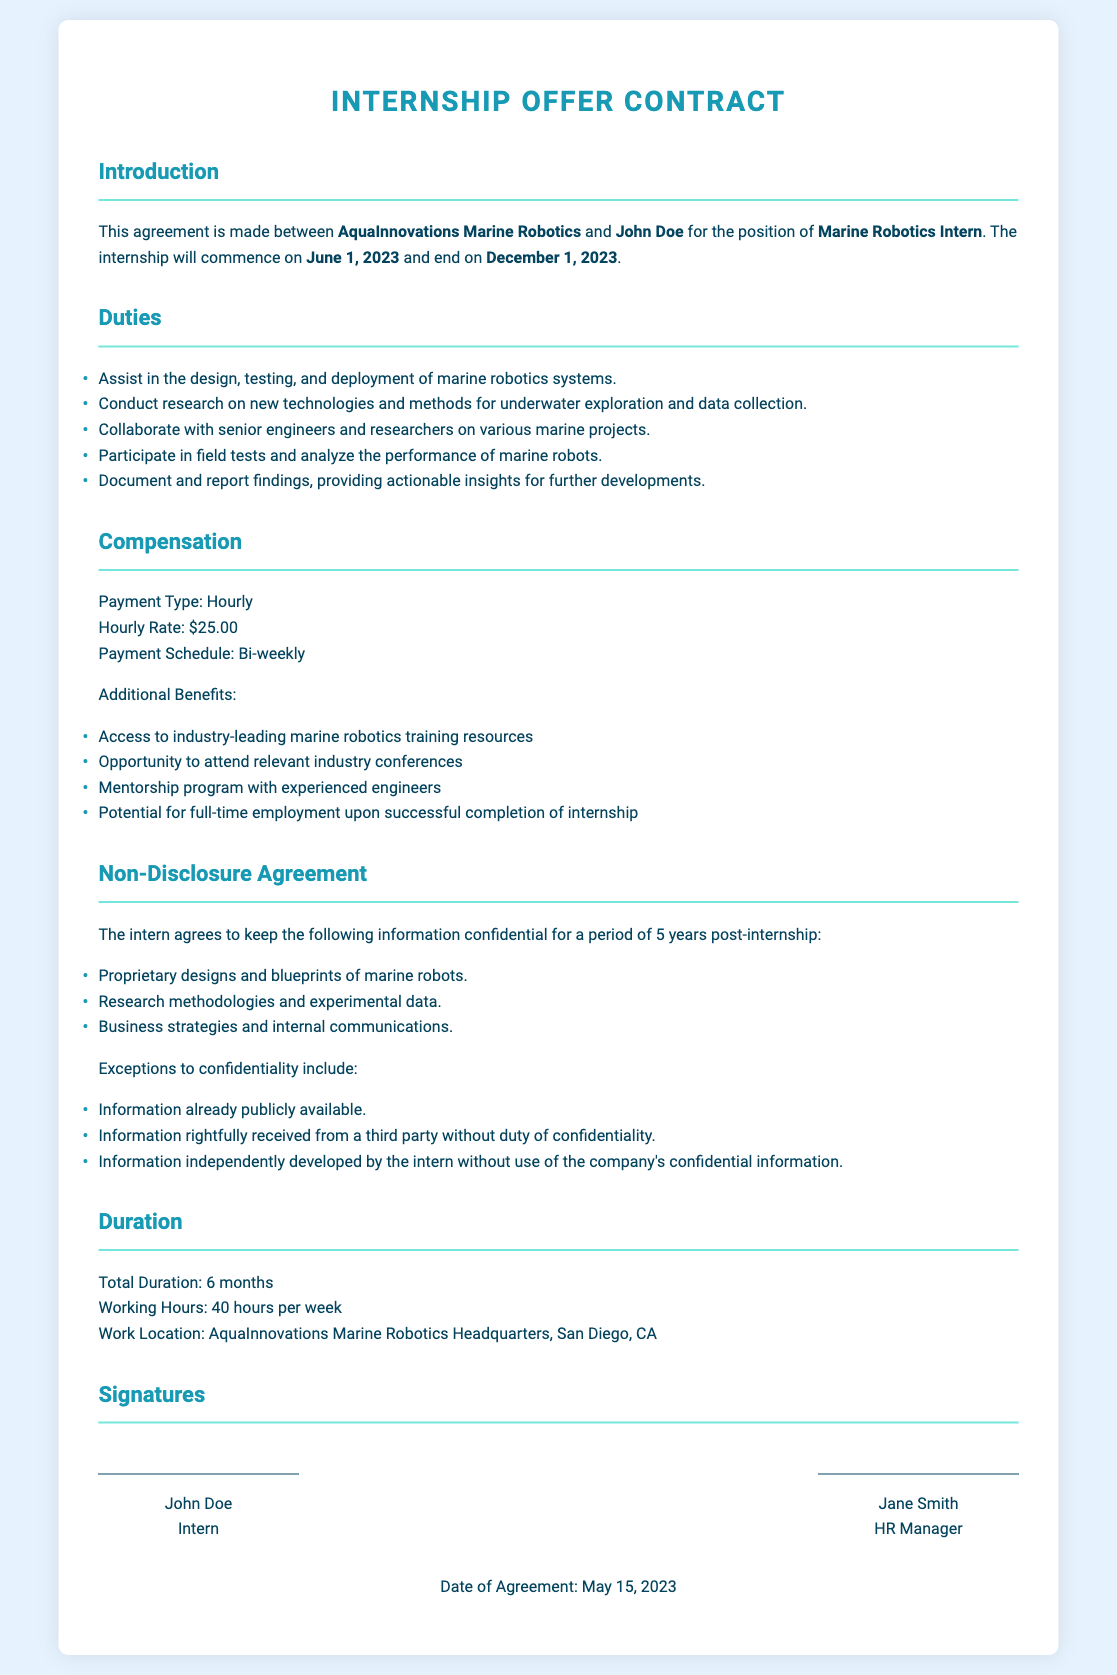What is the name of the marine robotics firm? The name of the firm is mentioned in the introduction section of the contract.
Answer: AquaInnovations Marine Robotics What is the position of the intern? The position is specified in the introduction part of the contract.
Answer: Marine Robotics Intern What is the hourly rate of compensation? The hourly rate is listed under the compensation section of the document.
Answer: $25.00 What is the duration of the internship? The total duration is stated in the duration section of the document.
Answer: 6 months On what date does the internship commence? The start date is specified in the introduction section of the contract.
Answer: June 1, 2023 What are the working hours per week? Working hours are mentioned in the duration section of the document.
Answer: 40 hours How long must confidential information be kept secret? The duration for keeping information confidential is indicated in the non-disclosure agreement section.
Answer: 5 years What is one additional benefit mentioned in the contract? The benefits are listed under the compensation section of the contract, and one is explicitly identified.
Answer: Access to industry-leading marine robotics training resources Who must sign the contract? Signatures are required from both the intern and a company representative, as indicated in the signatures section.
Answer: John Doe and Jane Smith 